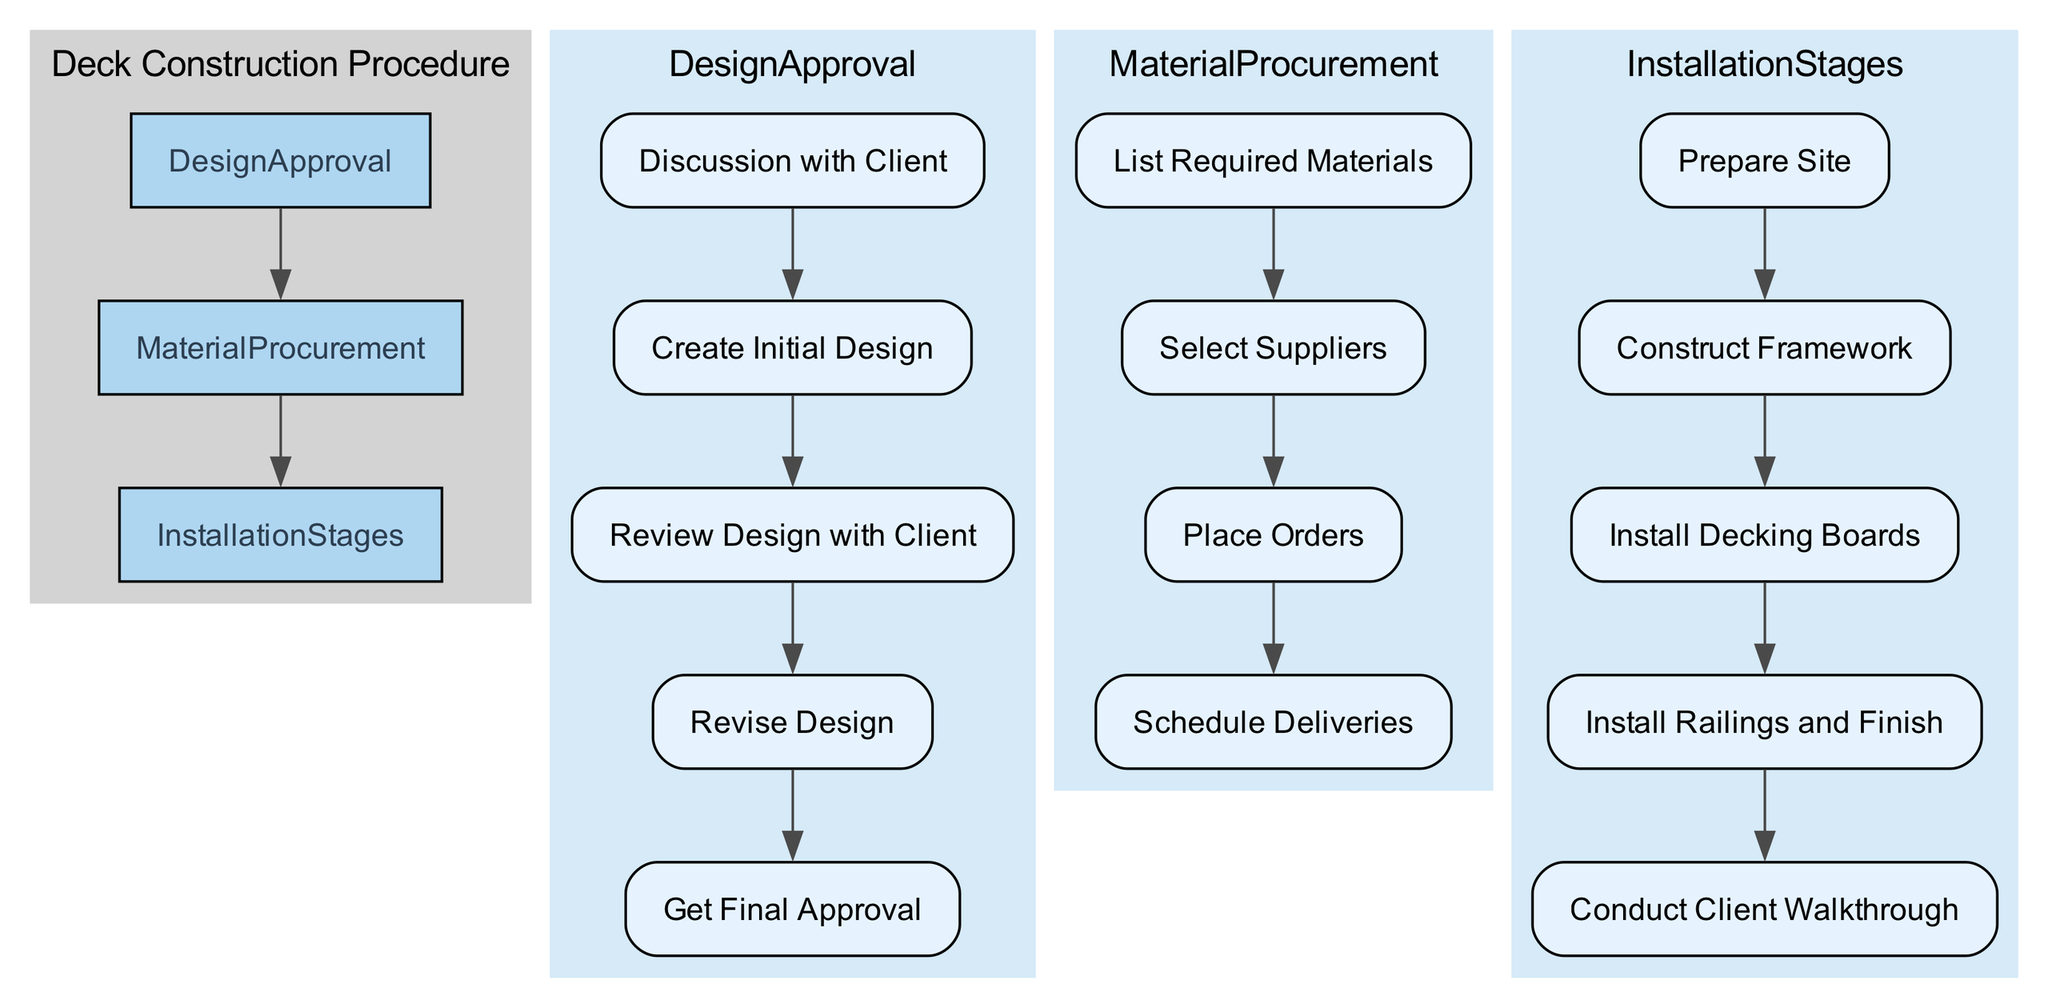What are the main stages in the deck construction procedure? The diagram presents three main stages: Design Approval, Material Procurement, and Installation Stages. Each stage has specific tasks or processes associated with it as outlined in the flowchart.
Answer: Design Approval, Material Procurement, Installation Stages How many sub-stages are there in the Design Approval phase? In the Design Approval stage, there are five sub-stages: Client Consultation, Initial Design, Client Feedback, Design Revision, and Final Approval. Counting these provides the answer.
Answer: 5 What is the first task in the Material Procurement stage? The Material Procurement stage starts with the task "List Required Materials." This is identified as the first element in that phase as per the flow chart.
Answer: List Required Materials Which task follows "Prepare Site" in the Installation Stages? After "Prepare Site," the next task in the Installation Stages is "Construct Framework." This is directly indicated in the flow of the diagram, showing the sequential order of tasks.
Answer: Construct Framework Is "Conduct Client Walkthrough" last in the Installation Stages? Yes, "Conduct Client Walkthrough" is the final task in the Installation Stages. The flow of the diagram shows this task as the last one before completing the procedure.
Answer: Yes What is the relationship between the Design Approval and Material Procurement stages? The Design Approval stage flows directly into the Material Procurement stage, indicating that once design approval is obtained, the next step is to procure materials. This is represented by an edge connecting the two stages in the flowchart.
Answer: Direct flow What is the tooltip for the "Revise Design" task? The tooltip for "Revise Design" describes the task as modifying the design according to the client's feedback. This is captured in the details associated with that node in the diagram.
Answer: Modify the design according to client's feedback How many edges connect the main stages in the chart? There are two edges connecting the main stages: one from Design Approval to Material Procurement and another from Material Procurement to Installation Stages. This can be counted by examining the connections shown in the diagram.
Answer: 2 What is the last task that needs client feedback in the Design Approval phase? The last task requiring client feedback in the Design Approval phase is "Review Design with Client." This task is positioned just before the final approval in the sequence of subtasks.
Answer: Review Design with Client 